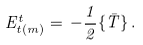<formula> <loc_0><loc_0><loc_500><loc_500>E ^ { t } _ { t ( m ) } = \, - \frac { 1 } { 2 } \{ \bar { T } \} \, .</formula> 